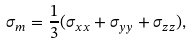<formula> <loc_0><loc_0><loc_500><loc_500>\sigma _ { m } = \frac { 1 } { 3 } ( \sigma _ { x x } + \sigma _ { y y } + \sigma _ { z z } ) ,</formula> 